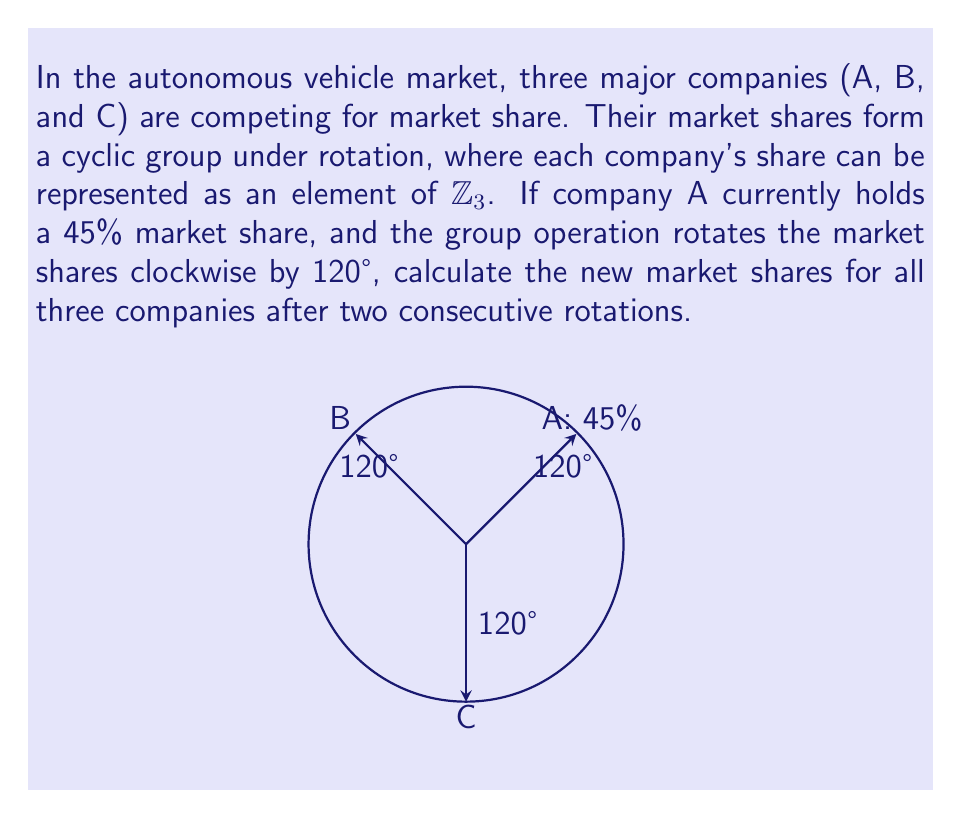Help me with this question. Let's approach this step-by-step:

1) We're working with a cyclic group of order 3, which can be represented as $\mathbb{Z}_3 = \{0, 1, 2\}$.

2) Let's assign the current state:
   A = 0 (45% market share)
   B = 1
   C = 2

3) The group operation is rotation by 120°, which in $\mathbb{Z}_3$ is equivalent to adding 1 (mod 3):
   $f(x) = (x + 1) \mod 3$

4) We need to apply this operation twice. This is equivalent to adding 2 (mod 3):
   $f(f(x)) = ((x + 1) + 1) \mod 3 = (x + 2) \mod 3$

5) Applying this to each company:
   A: $(0 + 2) \mod 3 = 2$
   B: $(1 + 2) \mod 3 = 0$
   C: $(2 + 2) \mod 3 = 1$

6) This means:
   A moves to C's position
   B moves to A's position (45% market share)
   C moves to B's position

7) To calculate the new market shares:
   B now has 45%
   A and C split the remaining 55% equally (as they've swapped positions)
   So A and C each have 27.5%

Therefore, after two rotations:
B: 45%
A: 27.5%
C: 27.5%
Answer: B: 45%, A: 27.5%, C: 27.5% 